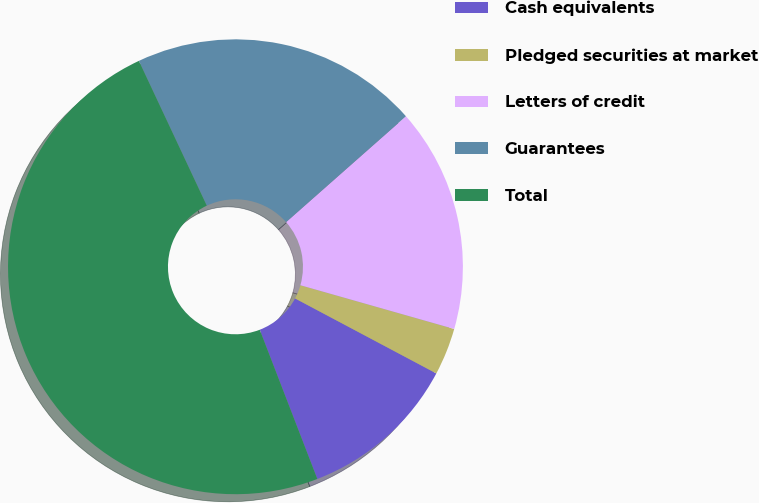<chart> <loc_0><loc_0><loc_500><loc_500><pie_chart><fcel>Cash equivalents<fcel>Pledged securities at market<fcel>Letters of credit<fcel>Guarantees<fcel>Total<nl><fcel>11.37%<fcel>3.36%<fcel>15.92%<fcel>20.47%<fcel>48.88%<nl></chart> 